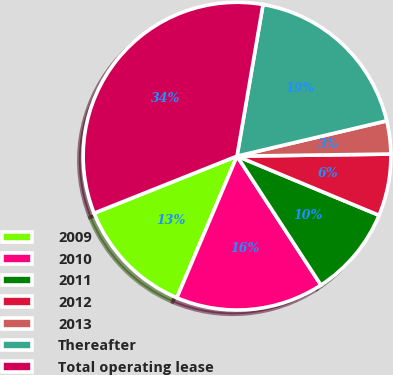Convert chart to OTSL. <chart><loc_0><loc_0><loc_500><loc_500><pie_chart><fcel>2009<fcel>2010<fcel>2011<fcel>2012<fcel>2013<fcel>Thereafter<fcel>Total operating lease<nl><fcel>12.56%<fcel>15.58%<fcel>9.53%<fcel>6.5%<fcel>3.47%<fcel>18.61%<fcel>33.75%<nl></chart> 